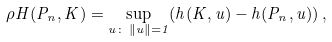Convert formula to latex. <formula><loc_0><loc_0><loc_500><loc_500>\rho H ( P _ { n } , K ) = \sup _ { u \colon \, \| u \| = 1 } ( h ( K , u ) - h ( P _ { n } , u ) ) \, ,</formula> 